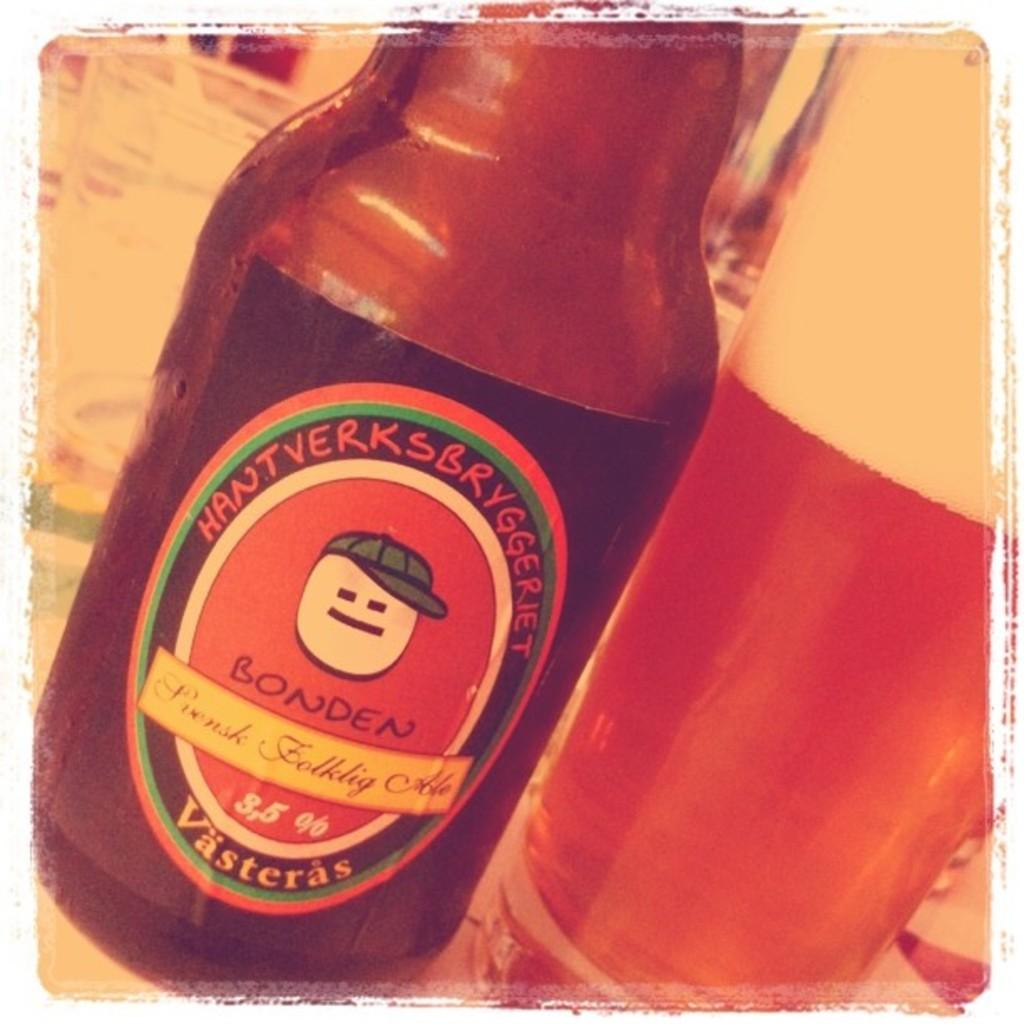Provide a one-sentence caption for the provided image. A bottle of Bonden beer is sitting next to a glass. 